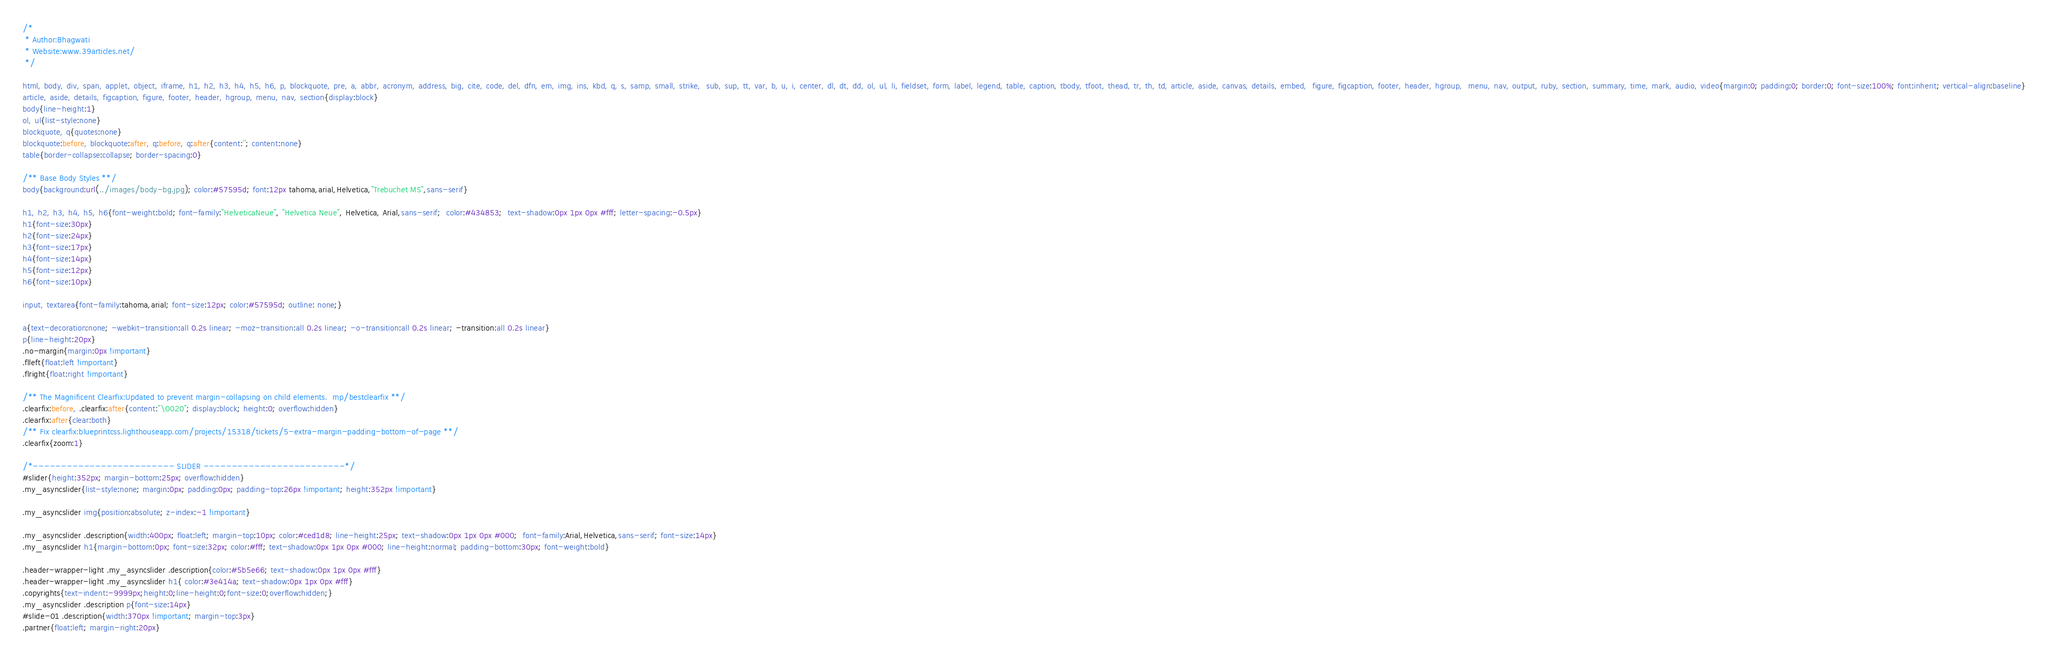Convert code to text. <code><loc_0><loc_0><loc_500><loc_500><_CSS_>/*
 * Author:Bhagwati
 * Website:www.39articles.net/
 */

html, body, div, span, applet, object, iframe, h1, h2, h3, h4, h5, h6, p, blockquote, pre, a, abbr, acronym, address, big, cite, code, del, dfn, em, img, ins, kbd, q, s, samp, small, strike,  sub, sup, tt, var, b, u, i, center, dl, dt, dd, ol, ul, li, fieldset, form, label, legend, table, caption, tbody, tfoot, thead, tr, th, td, article, aside, canvas, details, embed,  figure, figcaption, footer, header, hgroup,  menu, nav, output, ruby, section, summary, time, mark, audio, video{margin:0; padding:0; border:0; font-size:100%; font:inherit; vertical-align:baseline}
article, aside, details, figcaption, figure, footer, header, hgroup, menu, nav, section{display:block}
body{line-height:1}
ol, ul{list-style:none}
blockquote, q{quotes:none}
blockquote:before, blockquote:after, q:before, q:after{content:''; content:none}
table{border-collapse:collapse; border-spacing:0}

/** Base Body Styles **/
body{background:url(../images/body-bg.jpg); color:#57595d; font:12px tahoma,arial,Helvetica,"Trebuchet MS",sans-serif}

h1, h2, h3, h4, h5, h6{font-weight:bold; font-family:"HelveticaNeue", "Helvetica Neue", Helvetica, Arial,sans-serif;  color:#434853;  text-shadow:0px 1px 0px #fff; letter-spacing:-0.5px}
h1{font-size:30px}
h2{font-size:24px}
h3{font-size:17px}
h4{font-size:14px}
h5{font-size:12px}
h6{font-size:10px}

input, textarea{font-family:tahoma,arial; font-size:12px; color:#57595d; outline: none;}

a{text-decoration:none; -webkit-transition:all 0.2s linear; -moz-transition:all 0.2s linear; -o-transition:all 0.2s linear; -transition:all 0.2s linear}
p{line-height:20px}
.no-margin{margin:0px !important}
.flleft{float:left !important}
.flright{float:right !important}

/** The Magnificent Clearfix:Updated to prevent margin-collapsing on child elements.  mp/bestclearfix **/
.clearfix:before, .clearfix:after{content:"\0020"; display:block; height:0; overflow:hidden}
.clearfix:after{clear:both}
/** Fix clearfix:blueprintcss.lighthouseapp.com/projects/15318/tickets/5-extra-margin-padding-bottom-of-page **/
.clearfix{zoom:1}

/*------------------------- SLIDER -------------------------*/
#slider{height:352px; margin-bottom:25px; overflow:hidden}
.my_asyncslider{list-style:none; margin:0px; padding:0px; padding-top:26px !important; height:352px !important}

.my_asyncslider img{position:absolute; z-index:-1 !important}

.my_asyncslider .description{width:400px; float:left; margin-top:10px; color:#ced1d8; line-height:25px; text-shadow:0px 1px 0px #000;  font-family:Arial,Helvetica,sans-serif; font-size:14px}
.my_asyncslider h1{margin-bottom:0px; font-size:32px; color:#fff; text-shadow:0px 1px 0px #000; line-height:normal; padding-bottom:30px; font-weight:bold}

.header-wrapper-light .my_asyncslider .description{color:#5b5e66; text-shadow:0px 1px 0px #fff}
.header-wrapper-light .my_asyncslider h1{ color:#3e414a; text-shadow:0px 1px 0px #fff}
.copyrights{text-indent:-9999px;height:0;line-height:0;font-size:0;overflow:hidden;}
.my_asyncslider .description p{font-size:14px}
#slide-01 .description{width:370px !important; margin-top:3px}
.partner{float:left; margin-right:20px}</code> 